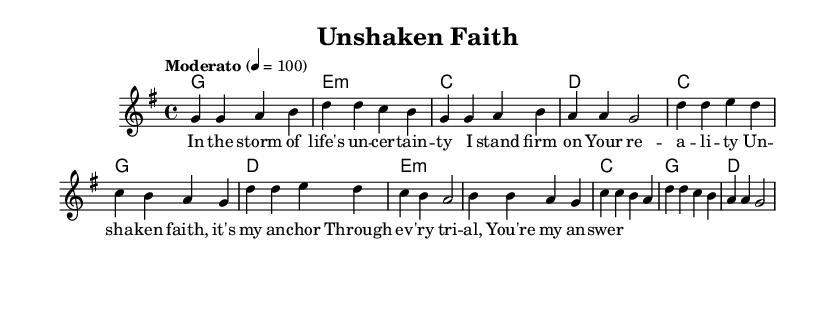What is the key signature of this music? The key signature indicates G major, which has one sharp (F#). This can be identified by looking at the key signature at the beginning of the staff.
Answer: G major What is the time signature of this piece? The time signature is 4/4, which is shown at the beginning of the sheet music. This means there are four beats in a measure, and the quarter note gets one beat.
Answer: 4/4 What is the tempo marking for this music? The tempo marking is "Moderato" with a metronome marking of 100. This indicates a moderate speed, allowing for an average pace in performance.
Answer: Moderato, 100 How many chords are indicated in the verses? By analyzing the chord symbols above the staff, there are four chords listed for the verse: G, E minor, C, and D. This count is deduced by noticing each unique chord symbol without repetition.
Answer: Four What is the structure of the song? The structure consists of a Verse, Chorus, and Bridge as indicated by the labeled sections in the melody and lyrics. Each label signifies a distinct section in the overall composition.
Answer: Verse, Chorus, Bridge How many measures are in the chorus? Counting the measures in the chorus section of the melody reveals four measures total. Each set of four beats represents one measure, and there are four distinct measures labeled as part of the chorus.
Answer: Four What type of music is indicated by the title "Unshaken Faith"? The title suggests it is a Christian rock song, as it combines themes of faith and resilience, which are often found in Christian rock genres. The word "faith" especially hints at its spiritual context.
Answer: Christian rock 